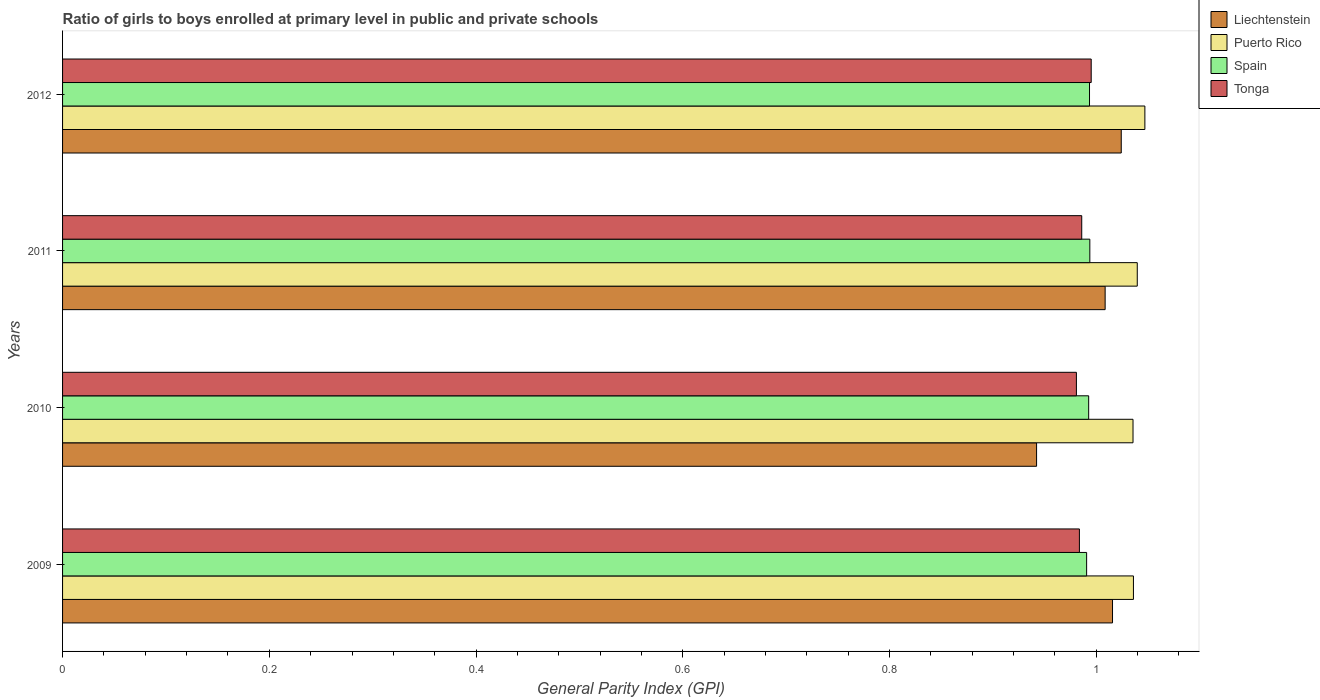Are the number of bars on each tick of the Y-axis equal?
Your answer should be very brief. Yes. How many bars are there on the 4th tick from the top?
Make the answer very short. 4. How many bars are there on the 3rd tick from the bottom?
Offer a terse response. 4. What is the general parity index in Puerto Rico in 2011?
Your answer should be very brief. 1.04. Across all years, what is the maximum general parity index in Spain?
Offer a terse response. 0.99. Across all years, what is the minimum general parity index in Spain?
Keep it short and to the point. 0.99. What is the total general parity index in Spain in the graph?
Make the answer very short. 3.97. What is the difference between the general parity index in Liechtenstein in 2010 and that in 2012?
Your answer should be compact. -0.08. What is the difference between the general parity index in Puerto Rico in 2010 and the general parity index in Tonga in 2012?
Your answer should be compact. 0.04. What is the average general parity index in Puerto Rico per year?
Provide a succinct answer. 1.04. In the year 2010, what is the difference between the general parity index in Puerto Rico and general parity index in Liechtenstein?
Provide a succinct answer. 0.09. What is the ratio of the general parity index in Spain in 2009 to that in 2010?
Offer a very short reply. 1. Is the difference between the general parity index in Puerto Rico in 2010 and 2011 greater than the difference between the general parity index in Liechtenstein in 2010 and 2011?
Make the answer very short. Yes. What is the difference between the highest and the second highest general parity index in Puerto Rico?
Provide a succinct answer. 0.01. What is the difference between the highest and the lowest general parity index in Tonga?
Offer a very short reply. 0.01. In how many years, is the general parity index in Tonga greater than the average general parity index in Tonga taken over all years?
Offer a very short reply. 1. Is the sum of the general parity index in Liechtenstein in 2010 and 2011 greater than the maximum general parity index in Spain across all years?
Give a very brief answer. Yes. What does the 1st bar from the top in 2012 represents?
Provide a short and direct response. Tonga. What does the 1st bar from the bottom in 2009 represents?
Provide a succinct answer. Liechtenstein. How many bars are there?
Ensure brevity in your answer.  16. Are the values on the major ticks of X-axis written in scientific E-notation?
Your answer should be compact. No. Does the graph contain any zero values?
Your answer should be compact. No. Where does the legend appear in the graph?
Your answer should be very brief. Top right. What is the title of the graph?
Your answer should be very brief. Ratio of girls to boys enrolled at primary level in public and private schools. What is the label or title of the X-axis?
Your answer should be compact. General Parity Index (GPI). What is the General Parity Index (GPI) in Liechtenstein in 2009?
Offer a very short reply. 1.02. What is the General Parity Index (GPI) in Puerto Rico in 2009?
Give a very brief answer. 1.04. What is the General Parity Index (GPI) of Spain in 2009?
Your answer should be compact. 0.99. What is the General Parity Index (GPI) of Tonga in 2009?
Keep it short and to the point. 0.98. What is the General Parity Index (GPI) in Liechtenstein in 2010?
Make the answer very short. 0.94. What is the General Parity Index (GPI) in Puerto Rico in 2010?
Offer a very short reply. 1.04. What is the General Parity Index (GPI) of Spain in 2010?
Provide a succinct answer. 0.99. What is the General Parity Index (GPI) of Tonga in 2010?
Make the answer very short. 0.98. What is the General Parity Index (GPI) in Liechtenstein in 2011?
Offer a very short reply. 1.01. What is the General Parity Index (GPI) of Puerto Rico in 2011?
Your answer should be very brief. 1.04. What is the General Parity Index (GPI) of Spain in 2011?
Offer a terse response. 0.99. What is the General Parity Index (GPI) of Tonga in 2011?
Keep it short and to the point. 0.99. What is the General Parity Index (GPI) of Liechtenstein in 2012?
Your answer should be compact. 1.02. What is the General Parity Index (GPI) in Puerto Rico in 2012?
Provide a short and direct response. 1.05. What is the General Parity Index (GPI) of Spain in 2012?
Ensure brevity in your answer.  0.99. What is the General Parity Index (GPI) of Tonga in 2012?
Offer a terse response. 1. Across all years, what is the maximum General Parity Index (GPI) of Liechtenstein?
Give a very brief answer. 1.02. Across all years, what is the maximum General Parity Index (GPI) in Puerto Rico?
Your response must be concise. 1.05. Across all years, what is the maximum General Parity Index (GPI) in Spain?
Your response must be concise. 0.99. Across all years, what is the maximum General Parity Index (GPI) in Tonga?
Your answer should be compact. 1. Across all years, what is the minimum General Parity Index (GPI) in Liechtenstein?
Keep it short and to the point. 0.94. Across all years, what is the minimum General Parity Index (GPI) of Puerto Rico?
Give a very brief answer. 1.04. Across all years, what is the minimum General Parity Index (GPI) of Spain?
Offer a very short reply. 0.99. Across all years, what is the minimum General Parity Index (GPI) of Tonga?
Ensure brevity in your answer.  0.98. What is the total General Parity Index (GPI) in Liechtenstein in the graph?
Your answer should be compact. 3.99. What is the total General Parity Index (GPI) of Puerto Rico in the graph?
Provide a short and direct response. 4.16. What is the total General Parity Index (GPI) in Spain in the graph?
Your answer should be compact. 3.97. What is the total General Parity Index (GPI) in Tonga in the graph?
Your answer should be very brief. 3.95. What is the difference between the General Parity Index (GPI) in Liechtenstein in 2009 and that in 2010?
Ensure brevity in your answer.  0.07. What is the difference between the General Parity Index (GPI) of Puerto Rico in 2009 and that in 2010?
Offer a terse response. 0. What is the difference between the General Parity Index (GPI) in Spain in 2009 and that in 2010?
Ensure brevity in your answer.  -0. What is the difference between the General Parity Index (GPI) in Tonga in 2009 and that in 2010?
Provide a short and direct response. 0. What is the difference between the General Parity Index (GPI) in Liechtenstein in 2009 and that in 2011?
Provide a succinct answer. 0.01. What is the difference between the General Parity Index (GPI) in Puerto Rico in 2009 and that in 2011?
Make the answer very short. -0. What is the difference between the General Parity Index (GPI) of Spain in 2009 and that in 2011?
Give a very brief answer. -0. What is the difference between the General Parity Index (GPI) of Tonga in 2009 and that in 2011?
Offer a very short reply. -0. What is the difference between the General Parity Index (GPI) in Liechtenstein in 2009 and that in 2012?
Ensure brevity in your answer.  -0.01. What is the difference between the General Parity Index (GPI) of Puerto Rico in 2009 and that in 2012?
Your answer should be very brief. -0.01. What is the difference between the General Parity Index (GPI) in Spain in 2009 and that in 2012?
Provide a short and direct response. -0. What is the difference between the General Parity Index (GPI) of Tonga in 2009 and that in 2012?
Your response must be concise. -0.01. What is the difference between the General Parity Index (GPI) in Liechtenstein in 2010 and that in 2011?
Provide a succinct answer. -0.07. What is the difference between the General Parity Index (GPI) of Puerto Rico in 2010 and that in 2011?
Offer a terse response. -0. What is the difference between the General Parity Index (GPI) in Spain in 2010 and that in 2011?
Offer a terse response. -0. What is the difference between the General Parity Index (GPI) of Tonga in 2010 and that in 2011?
Your answer should be very brief. -0.01. What is the difference between the General Parity Index (GPI) in Liechtenstein in 2010 and that in 2012?
Make the answer very short. -0.08. What is the difference between the General Parity Index (GPI) of Puerto Rico in 2010 and that in 2012?
Your answer should be very brief. -0.01. What is the difference between the General Parity Index (GPI) in Spain in 2010 and that in 2012?
Offer a terse response. -0. What is the difference between the General Parity Index (GPI) in Tonga in 2010 and that in 2012?
Make the answer very short. -0.01. What is the difference between the General Parity Index (GPI) in Liechtenstein in 2011 and that in 2012?
Keep it short and to the point. -0.02. What is the difference between the General Parity Index (GPI) in Puerto Rico in 2011 and that in 2012?
Offer a terse response. -0.01. What is the difference between the General Parity Index (GPI) in Tonga in 2011 and that in 2012?
Make the answer very short. -0.01. What is the difference between the General Parity Index (GPI) in Liechtenstein in 2009 and the General Parity Index (GPI) in Puerto Rico in 2010?
Offer a very short reply. -0.02. What is the difference between the General Parity Index (GPI) of Liechtenstein in 2009 and the General Parity Index (GPI) of Spain in 2010?
Provide a succinct answer. 0.02. What is the difference between the General Parity Index (GPI) in Liechtenstein in 2009 and the General Parity Index (GPI) in Tonga in 2010?
Offer a very short reply. 0.03. What is the difference between the General Parity Index (GPI) of Puerto Rico in 2009 and the General Parity Index (GPI) of Spain in 2010?
Make the answer very short. 0.04. What is the difference between the General Parity Index (GPI) of Puerto Rico in 2009 and the General Parity Index (GPI) of Tonga in 2010?
Make the answer very short. 0.06. What is the difference between the General Parity Index (GPI) of Spain in 2009 and the General Parity Index (GPI) of Tonga in 2010?
Make the answer very short. 0.01. What is the difference between the General Parity Index (GPI) in Liechtenstein in 2009 and the General Parity Index (GPI) in Puerto Rico in 2011?
Give a very brief answer. -0.02. What is the difference between the General Parity Index (GPI) in Liechtenstein in 2009 and the General Parity Index (GPI) in Spain in 2011?
Your answer should be very brief. 0.02. What is the difference between the General Parity Index (GPI) in Liechtenstein in 2009 and the General Parity Index (GPI) in Tonga in 2011?
Provide a succinct answer. 0.03. What is the difference between the General Parity Index (GPI) of Puerto Rico in 2009 and the General Parity Index (GPI) of Spain in 2011?
Provide a succinct answer. 0.04. What is the difference between the General Parity Index (GPI) in Puerto Rico in 2009 and the General Parity Index (GPI) in Tonga in 2011?
Provide a succinct answer. 0.05. What is the difference between the General Parity Index (GPI) of Spain in 2009 and the General Parity Index (GPI) of Tonga in 2011?
Keep it short and to the point. 0. What is the difference between the General Parity Index (GPI) in Liechtenstein in 2009 and the General Parity Index (GPI) in Puerto Rico in 2012?
Make the answer very short. -0.03. What is the difference between the General Parity Index (GPI) in Liechtenstein in 2009 and the General Parity Index (GPI) in Spain in 2012?
Offer a terse response. 0.02. What is the difference between the General Parity Index (GPI) in Liechtenstein in 2009 and the General Parity Index (GPI) in Tonga in 2012?
Your answer should be very brief. 0.02. What is the difference between the General Parity Index (GPI) in Puerto Rico in 2009 and the General Parity Index (GPI) in Spain in 2012?
Offer a very short reply. 0.04. What is the difference between the General Parity Index (GPI) in Puerto Rico in 2009 and the General Parity Index (GPI) in Tonga in 2012?
Give a very brief answer. 0.04. What is the difference between the General Parity Index (GPI) of Spain in 2009 and the General Parity Index (GPI) of Tonga in 2012?
Your answer should be very brief. -0. What is the difference between the General Parity Index (GPI) of Liechtenstein in 2010 and the General Parity Index (GPI) of Puerto Rico in 2011?
Offer a very short reply. -0.1. What is the difference between the General Parity Index (GPI) of Liechtenstein in 2010 and the General Parity Index (GPI) of Spain in 2011?
Ensure brevity in your answer.  -0.05. What is the difference between the General Parity Index (GPI) in Liechtenstein in 2010 and the General Parity Index (GPI) in Tonga in 2011?
Your answer should be compact. -0.04. What is the difference between the General Parity Index (GPI) of Puerto Rico in 2010 and the General Parity Index (GPI) of Spain in 2011?
Keep it short and to the point. 0.04. What is the difference between the General Parity Index (GPI) in Puerto Rico in 2010 and the General Parity Index (GPI) in Tonga in 2011?
Make the answer very short. 0.05. What is the difference between the General Parity Index (GPI) in Spain in 2010 and the General Parity Index (GPI) in Tonga in 2011?
Offer a terse response. 0.01. What is the difference between the General Parity Index (GPI) of Liechtenstein in 2010 and the General Parity Index (GPI) of Puerto Rico in 2012?
Give a very brief answer. -0.1. What is the difference between the General Parity Index (GPI) in Liechtenstein in 2010 and the General Parity Index (GPI) in Spain in 2012?
Your answer should be compact. -0.05. What is the difference between the General Parity Index (GPI) of Liechtenstein in 2010 and the General Parity Index (GPI) of Tonga in 2012?
Provide a succinct answer. -0.05. What is the difference between the General Parity Index (GPI) in Puerto Rico in 2010 and the General Parity Index (GPI) in Spain in 2012?
Your response must be concise. 0.04. What is the difference between the General Parity Index (GPI) of Puerto Rico in 2010 and the General Parity Index (GPI) of Tonga in 2012?
Provide a succinct answer. 0.04. What is the difference between the General Parity Index (GPI) of Spain in 2010 and the General Parity Index (GPI) of Tonga in 2012?
Offer a very short reply. -0. What is the difference between the General Parity Index (GPI) in Liechtenstein in 2011 and the General Parity Index (GPI) in Puerto Rico in 2012?
Offer a terse response. -0.04. What is the difference between the General Parity Index (GPI) in Liechtenstein in 2011 and the General Parity Index (GPI) in Spain in 2012?
Make the answer very short. 0.02. What is the difference between the General Parity Index (GPI) of Liechtenstein in 2011 and the General Parity Index (GPI) of Tonga in 2012?
Provide a short and direct response. 0.01. What is the difference between the General Parity Index (GPI) of Puerto Rico in 2011 and the General Parity Index (GPI) of Spain in 2012?
Your answer should be compact. 0.05. What is the difference between the General Parity Index (GPI) in Puerto Rico in 2011 and the General Parity Index (GPI) in Tonga in 2012?
Keep it short and to the point. 0.04. What is the difference between the General Parity Index (GPI) of Spain in 2011 and the General Parity Index (GPI) of Tonga in 2012?
Provide a short and direct response. -0. What is the average General Parity Index (GPI) in Puerto Rico per year?
Offer a very short reply. 1.04. What is the average General Parity Index (GPI) in Spain per year?
Provide a succinct answer. 0.99. What is the average General Parity Index (GPI) in Tonga per year?
Give a very brief answer. 0.99. In the year 2009, what is the difference between the General Parity Index (GPI) in Liechtenstein and General Parity Index (GPI) in Puerto Rico?
Make the answer very short. -0.02. In the year 2009, what is the difference between the General Parity Index (GPI) of Liechtenstein and General Parity Index (GPI) of Spain?
Your answer should be very brief. 0.03. In the year 2009, what is the difference between the General Parity Index (GPI) of Liechtenstein and General Parity Index (GPI) of Tonga?
Make the answer very short. 0.03. In the year 2009, what is the difference between the General Parity Index (GPI) in Puerto Rico and General Parity Index (GPI) in Spain?
Give a very brief answer. 0.05. In the year 2009, what is the difference between the General Parity Index (GPI) of Puerto Rico and General Parity Index (GPI) of Tonga?
Your response must be concise. 0.05. In the year 2009, what is the difference between the General Parity Index (GPI) of Spain and General Parity Index (GPI) of Tonga?
Your response must be concise. 0.01. In the year 2010, what is the difference between the General Parity Index (GPI) of Liechtenstein and General Parity Index (GPI) of Puerto Rico?
Offer a very short reply. -0.09. In the year 2010, what is the difference between the General Parity Index (GPI) in Liechtenstein and General Parity Index (GPI) in Spain?
Make the answer very short. -0.05. In the year 2010, what is the difference between the General Parity Index (GPI) of Liechtenstein and General Parity Index (GPI) of Tonga?
Provide a short and direct response. -0.04. In the year 2010, what is the difference between the General Parity Index (GPI) in Puerto Rico and General Parity Index (GPI) in Spain?
Give a very brief answer. 0.04. In the year 2010, what is the difference between the General Parity Index (GPI) in Puerto Rico and General Parity Index (GPI) in Tonga?
Ensure brevity in your answer.  0.05. In the year 2010, what is the difference between the General Parity Index (GPI) of Spain and General Parity Index (GPI) of Tonga?
Offer a very short reply. 0.01. In the year 2011, what is the difference between the General Parity Index (GPI) of Liechtenstein and General Parity Index (GPI) of Puerto Rico?
Provide a succinct answer. -0.03. In the year 2011, what is the difference between the General Parity Index (GPI) of Liechtenstein and General Parity Index (GPI) of Spain?
Keep it short and to the point. 0.01. In the year 2011, what is the difference between the General Parity Index (GPI) of Liechtenstein and General Parity Index (GPI) of Tonga?
Your answer should be compact. 0.02. In the year 2011, what is the difference between the General Parity Index (GPI) in Puerto Rico and General Parity Index (GPI) in Spain?
Your answer should be compact. 0.05. In the year 2011, what is the difference between the General Parity Index (GPI) in Puerto Rico and General Parity Index (GPI) in Tonga?
Your answer should be compact. 0.05. In the year 2011, what is the difference between the General Parity Index (GPI) of Spain and General Parity Index (GPI) of Tonga?
Your answer should be very brief. 0.01. In the year 2012, what is the difference between the General Parity Index (GPI) of Liechtenstein and General Parity Index (GPI) of Puerto Rico?
Ensure brevity in your answer.  -0.02. In the year 2012, what is the difference between the General Parity Index (GPI) of Liechtenstein and General Parity Index (GPI) of Spain?
Give a very brief answer. 0.03. In the year 2012, what is the difference between the General Parity Index (GPI) of Liechtenstein and General Parity Index (GPI) of Tonga?
Offer a terse response. 0.03. In the year 2012, what is the difference between the General Parity Index (GPI) in Puerto Rico and General Parity Index (GPI) in Spain?
Make the answer very short. 0.05. In the year 2012, what is the difference between the General Parity Index (GPI) of Puerto Rico and General Parity Index (GPI) of Tonga?
Your answer should be very brief. 0.05. In the year 2012, what is the difference between the General Parity Index (GPI) of Spain and General Parity Index (GPI) of Tonga?
Keep it short and to the point. -0. What is the ratio of the General Parity Index (GPI) in Liechtenstein in 2009 to that in 2010?
Provide a short and direct response. 1.08. What is the ratio of the General Parity Index (GPI) of Puerto Rico in 2009 to that in 2010?
Offer a very short reply. 1. What is the ratio of the General Parity Index (GPI) of Spain in 2009 to that in 2010?
Offer a terse response. 1. What is the ratio of the General Parity Index (GPI) of Tonga in 2009 to that in 2010?
Offer a very short reply. 1. What is the ratio of the General Parity Index (GPI) in Liechtenstein in 2009 to that in 2011?
Provide a succinct answer. 1.01. What is the ratio of the General Parity Index (GPI) of Puerto Rico in 2009 to that in 2011?
Keep it short and to the point. 1. What is the ratio of the General Parity Index (GPI) of Tonga in 2009 to that in 2011?
Ensure brevity in your answer.  1. What is the ratio of the General Parity Index (GPI) of Liechtenstein in 2009 to that in 2012?
Provide a succinct answer. 0.99. What is the ratio of the General Parity Index (GPI) in Puerto Rico in 2009 to that in 2012?
Your answer should be compact. 0.99. What is the ratio of the General Parity Index (GPI) of Tonga in 2009 to that in 2012?
Provide a succinct answer. 0.99. What is the ratio of the General Parity Index (GPI) of Liechtenstein in 2010 to that in 2011?
Your response must be concise. 0.93. What is the ratio of the General Parity Index (GPI) of Puerto Rico in 2010 to that in 2011?
Offer a very short reply. 1. What is the ratio of the General Parity Index (GPI) of Spain in 2010 to that in 2011?
Give a very brief answer. 1. What is the ratio of the General Parity Index (GPI) of Tonga in 2010 to that in 2011?
Ensure brevity in your answer.  0.99. What is the ratio of the General Parity Index (GPI) of Puerto Rico in 2010 to that in 2012?
Offer a terse response. 0.99. What is the ratio of the General Parity Index (GPI) in Tonga in 2010 to that in 2012?
Your answer should be compact. 0.99. What is the ratio of the General Parity Index (GPI) in Liechtenstein in 2011 to that in 2012?
Your answer should be compact. 0.98. What is the ratio of the General Parity Index (GPI) of Puerto Rico in 2011 to that in 2012?
Give a very brief answer. 0.99. What is the ratio of the General Parity Index (GPI) in Spain in 2011 to that in 2012?
Your answer should be very brief. 1. What is the ratio of the General Parity Index (GPI) in Tonga in 2011 to that in 2012?
Your response must be concise. 0.99. What is the difference between the highest and the second highest General Parity Index (GPI) in Liechtenstein?
Provide a short and direct response. 0.01. What is the difference between the highest and the second highest General Parity Index (GPI) in Puerto Rico?
Your answer should be compact. 0.01. What is the difference between the highest and the second highest General Parity Index (GPI) of Tonga?
Provide a short and direct response. 0.01. What is the difference between the highest and the lowest General Parity Index (GPI) in Liechtenstein?
Keep it short and to the point. 0.08. What is the difference between the highest and the lowest General Parity Index (GPI) of Puerto Rico?
Keep it short and to the point. 0.01. What is the difference between the highest and the lowest General Parity Index (GPI) of Spain?
Offer a terse response. 0. What is the difference between the highest and the lowest General Parity Index (GPI) in Tonga?
Offer a terse response. 0.01. 